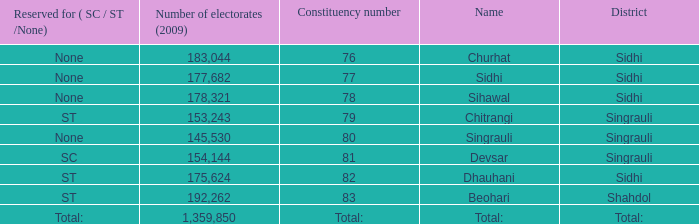What is Beohari's reserved for (SC/ST/None)? ST. 